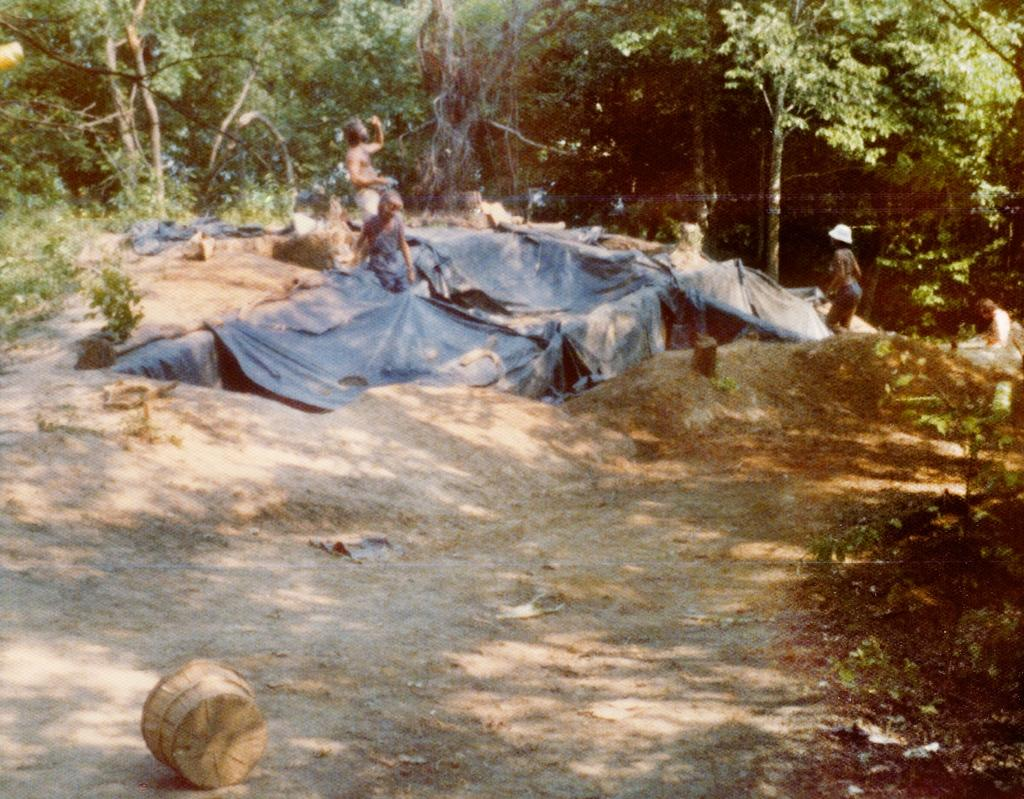How many people are in the image? There are people in the image, but the exact number is not specified. What are the people wearing? The people in the image are wearing clothes. Can you describe any specific clothing item in the image? One person is wearing a cap. What objects can be seen in the image besides the people? There is a wooden basket in the image. What type of environment is depicted in the image? Grass and trees are present in the image, suggesting a natural setting. How does the grass cry in the image? Grass does not have the ability to cry, as it is a plant and not a living being capable of expressing emotions. 